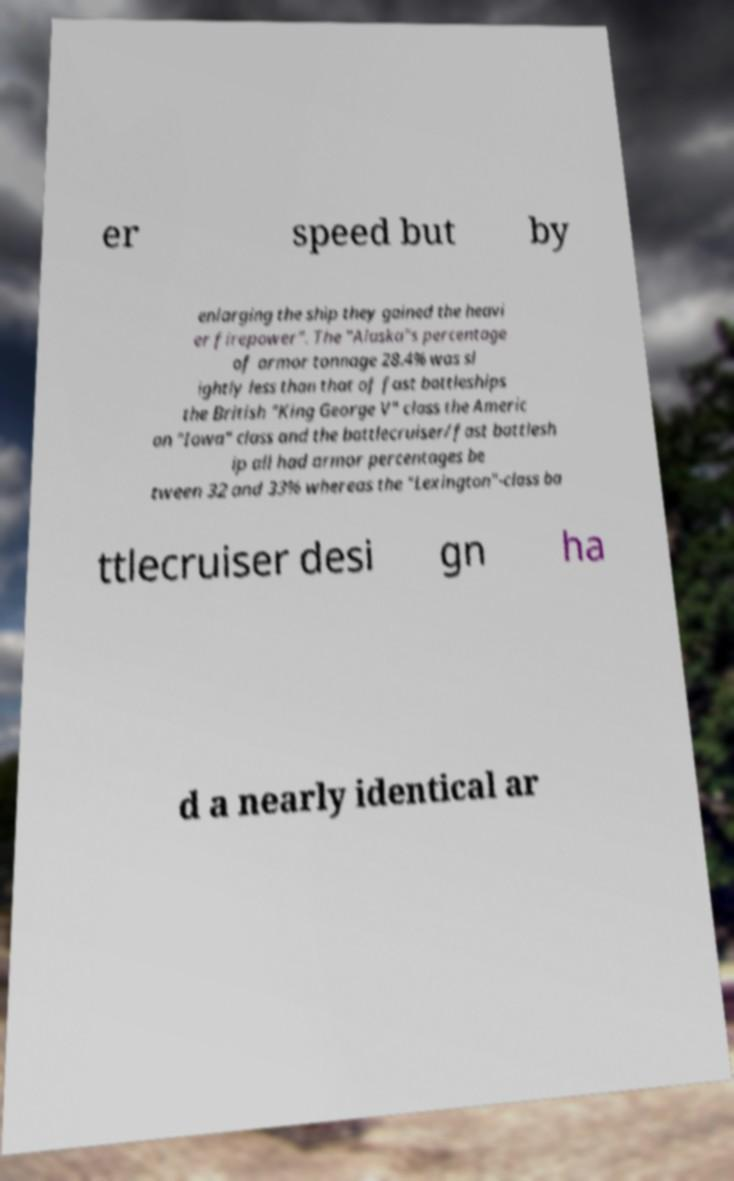Please identify and transcribe the text found in this image. er speed but by enlarging the ship they gained the heavi er firepower". The "Alaska"s percentage of armor tonnage 28.4% was sl ightly less than that of fast battleships the British "King George V" class the Americ an "Iowa" class and the battlecruiser/fast battlesh ip all had armor percentages be tween 32 and 33% whereas the "Lexington"-class ba ttlecruiser desi gn ha d a nearly identical ar 